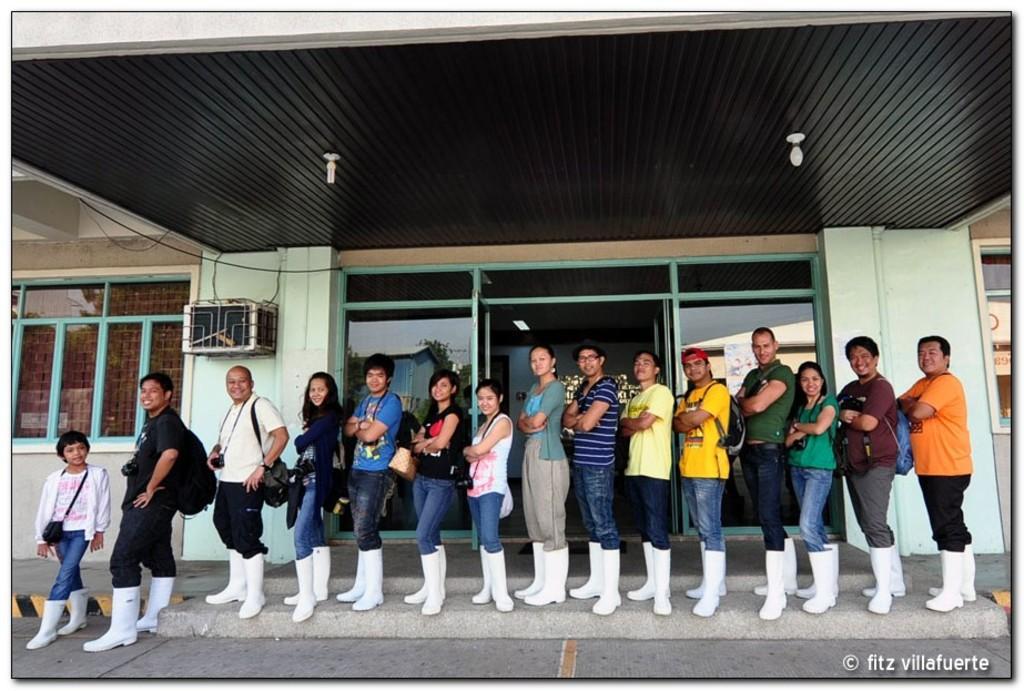Can you describe this image briefly? In this image I can see number of persons wearing white colored boots are standing. I can see the black colored ceiling, two lights to the ceiling and a building. I can see few windows and the glass door in which I can see the reflection of a building, the sky and few trees. 